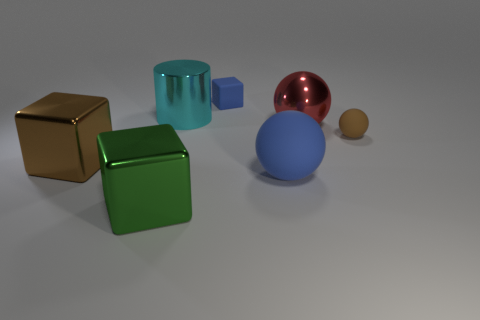There is another thing that is the same color as the big rubber thing; what is its material?
Your answer should be compact. Rubber. What number of shiny things are either big cyan objects or big blue things?
Provide a succinct answer. 1. The green shiny cube has what size?
Make the answer very short. Large. How many things are either small brown balls or things on the right side of the cyan thing?
Ensure brevity in your answer.  4. What number of other things are there of the same color as the large metal sphere?
Your answer should be very brief. 0. There is a cylinder; is it the same size as the object that is on the left side of the large green block?
Your response must be concise. Yes. Is the size of the green shiny block that is left of the cyan shiny cylinder the same as the blue matte block?
Your answer should be compact. No. How many other things are there of the same material as the blue block?
Make the answer very short. 2. Are there the same number of big cyan metallic cylinders that are to the right of the big cylinder and small objects that are behind the big red metallic sphere?
Your answer should be compact. No. There is a sphere that is behind the brown object to the right of the brown thing on the left side of the large cyan metal thing; what is its color?
Offer a terse response. Red. 